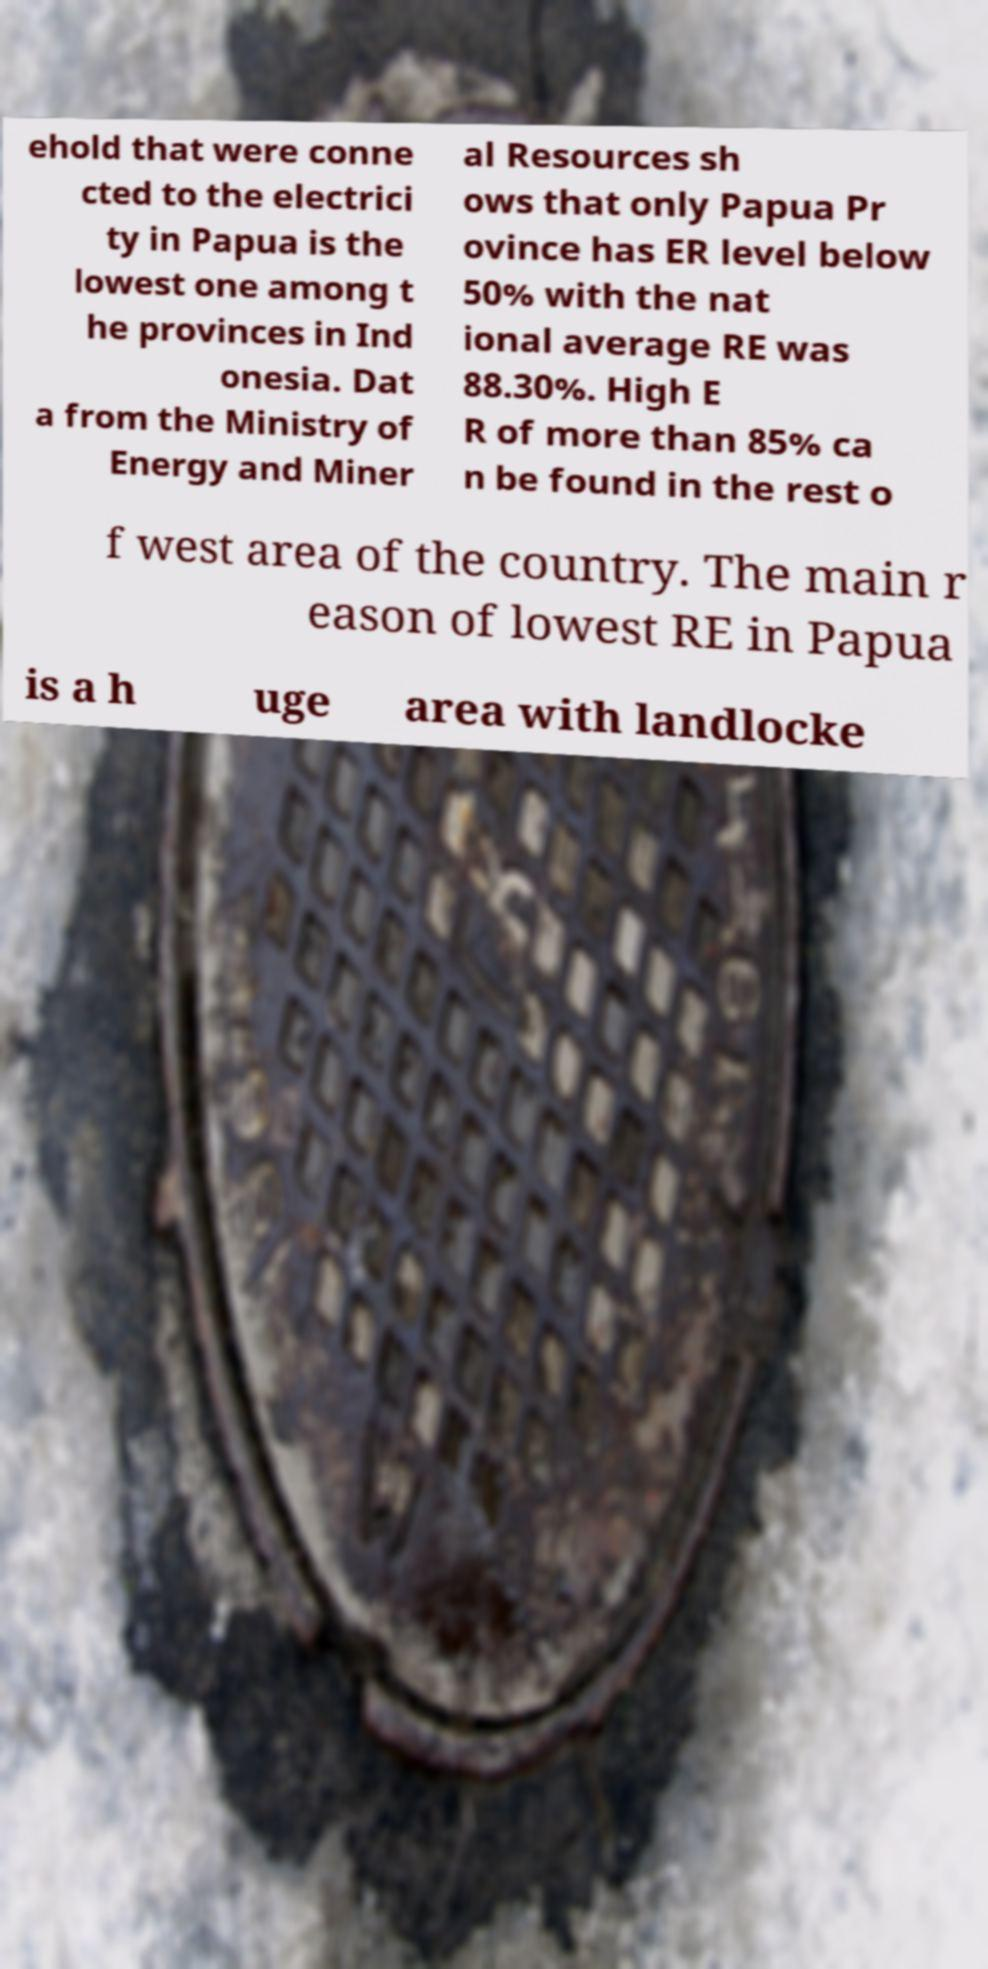For documentation purposes, I need the text within this image transcribed. Could you provide that? ehold that were conne cted to the electrici ty in Papua is the lowest one among t he provinces in Ind onesia. Dat a from the Ministry of Energy and Miner al Resources sh ows that only Papua Pr ovince has ER level below 50% with the nat ional average RE was 88.30%. High E R of more than 85% ca n be found in the rest o f west area of the country. The main r eason of lowest RE in Papua is a h uge area with landlocke 